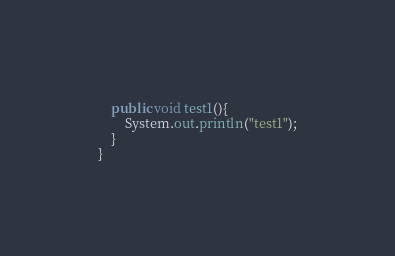Convert code to text. <code><loc_0><loc_0><loc_500><loc_500><_Java_>    public void test1(){
        System.out.println("test1");
    }
}
</code> 